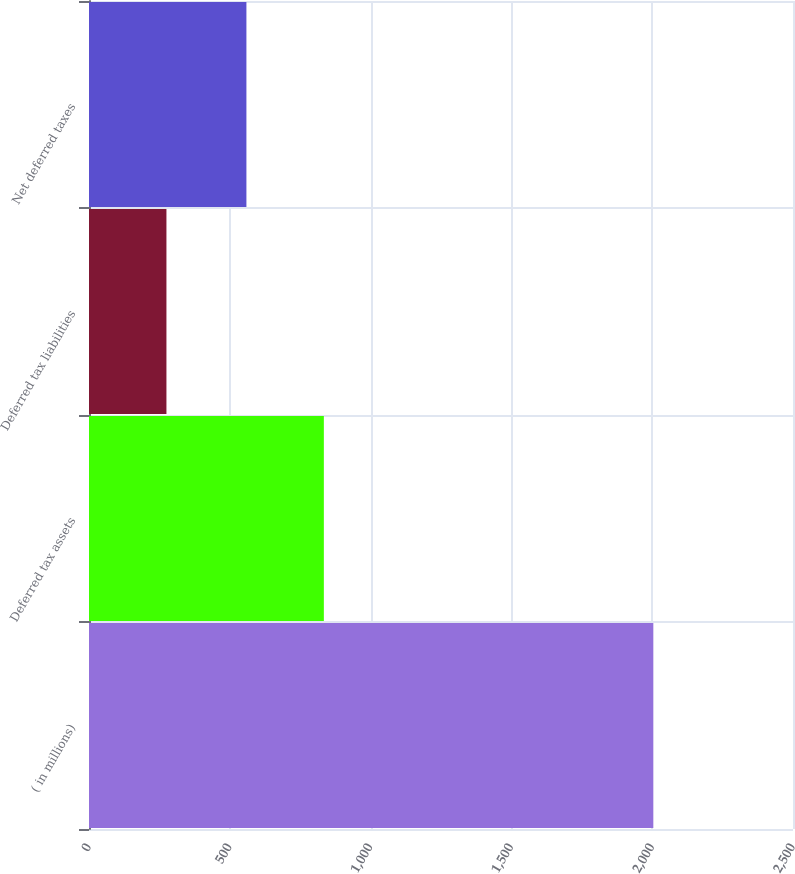Convert chart. <chart><loc_0><loc_0><loc_500><loc_500><bar_chart><fcel>( in millions)<fcel>Deferred tax assets<fcel>Deferred tax liabilities<fcel>Net deferred taxes<nl><fcel>2004<fcel>834<fcel>275<fcel>559<nl></chart> 